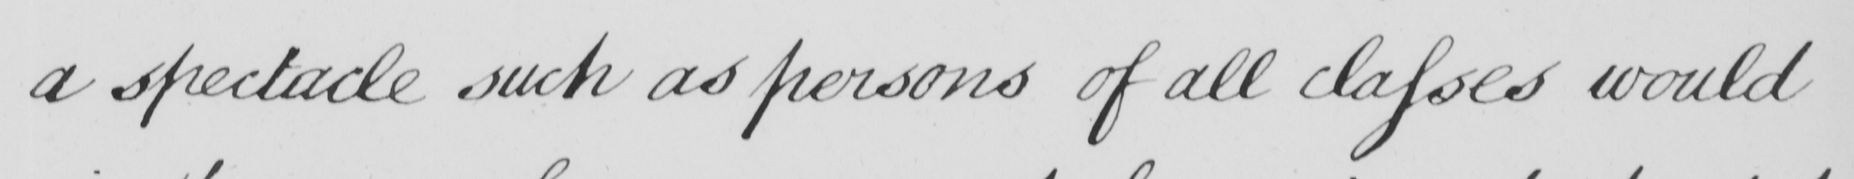Can you tell me what this handwritten text says? a spectacle such as persons of all classes would 